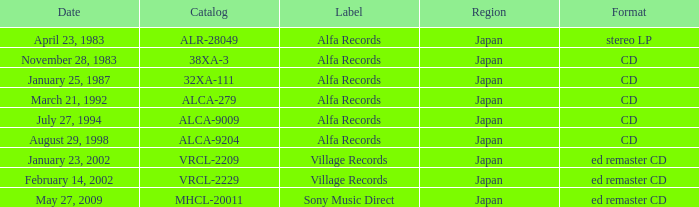Which date is in CD format? November 28, 1983, January 25, 1987, March 21, 1992, July 27, 1994, August 29, 1998. 